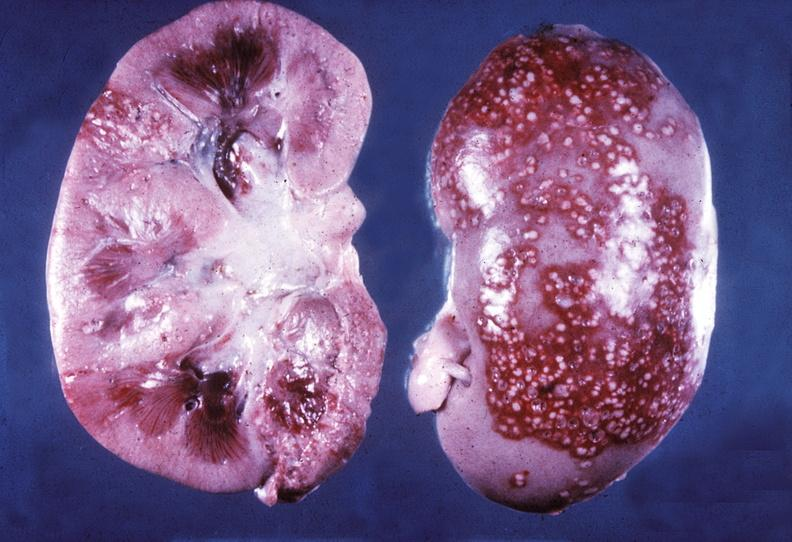does teratocarcinoma show kidney, pyelonephritis, acute?
Answer the question using a single word or phrase. No 